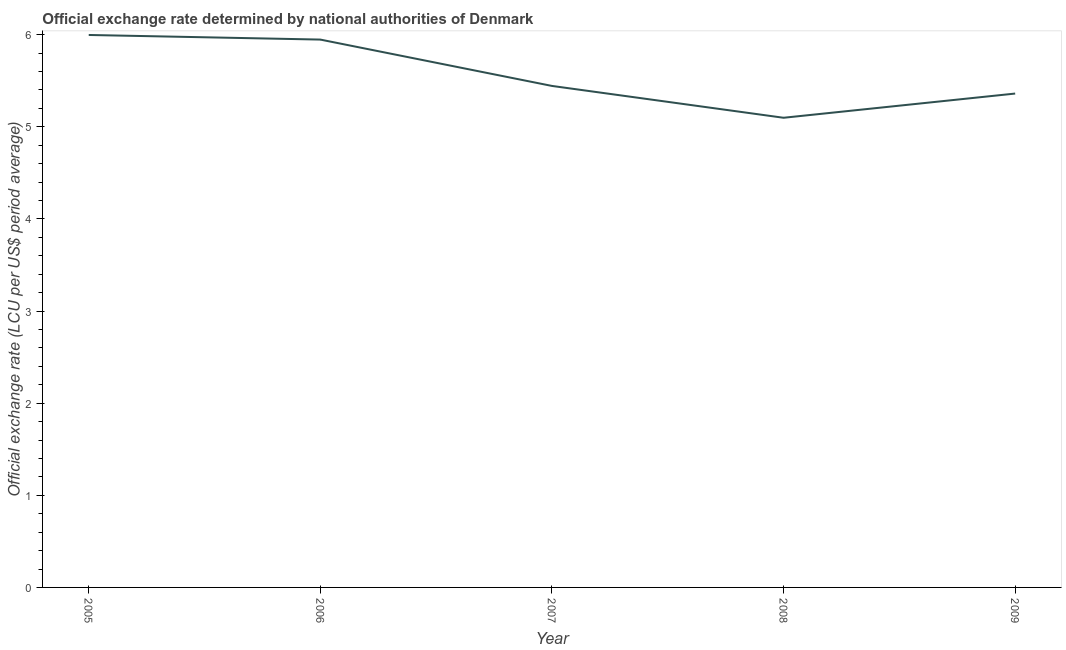What is the official exchange rate in 2009?
Your answer should be very brief. 5.36. Across all years, what is the maximum official exchange rate?
Offer a terse response. 6. Across all years, what is the minimum official exchange rate?
Offer a very short reply. 5.1. What is the sum of the official exchange rate?
Your answer should be compact. 27.85. What is the difference between the official exchange rate in 2006 and 2009?
Give a very brief answer. 0.59. What is the average official exchange rate per year?
Offer a very short reply. 5.57. What is the median official exchange rate?
Your answer should be compact. 5.44. Do a majority of the years between 2005 and 2007 (inclusive) have official exchange rate greater than 2.8 ?
Make the answer very short. Yes. What is the ratio of the official exchange rate in 2006 to that in 2007?
Ensure brevity in your answer.  1.09. Is the difference between the official exchange rate in 2006 and 2009 greater than the difference between any two years?
Offer a very short reply. No. What is the difference between the highest and the second highest official exchange rate?
Offer a very short reply. 0.05. Is the sum of the official exchange rate in 2007 and 2008 greater than the maximum official exchange rate across all years?
Your answer should be very brief. Yes. What is the difference between the highest and the lowest official exchange rate?
Provide a succinct answer. 0.9. Does the official exchange rate monotonically increase over the years?
Make the answer very short. No. How many lines are there?
Ensure brevity in your answer.  1. Are the values on the major ticks of Y-axis written in scientific E-notation?
Your response must be concise. No. Does the graph contain any zero values?
Offer a very short reply. No. Does the graph contain grids?
Provide a succinct answer. No. What is the title of the graph?
Make the answer very short. Official exchange rate determined by national authorities of Denmark. What is the label or title of the X-axis?
Your answer should be compact. Year. What is the label or title of the Y-axis?
Offer a very short reply. Official exchange rate (LCU per US$ period average). What is the Official exchange rate (LCU per US$ period average) in 2005?
Give a very brief answer. 6. What is the Official exchange rate (LCU per US$ period average) of 2006?
Your answer should be very brief. 5.95. What is the Official exchange rate (LCU per US$ period average) of 2007?
Your answer should be very brief. 5.44. What is the Official exchange rate (LCU per US$ period average) of 2008?
Give a very brief answer. 5.1. What is the Official exchange rate (LCU per US$ period average) of 2009?
Provide a succinct answer. 5.36. What is the difference between the Official exchange rate (LCU per US$ period average) in 2005 and 2006?
Give a very brief answer. 0.05. What is the difference between the Official exchange rate (LCU per US$ period average) in 2005 and 2007?
Make the answer very short. 0.55. What is the difference between the Official exchange rate (LCU per US$ period average) in 2005 and 2008?
Give a very brief answer. 0.9. What is the difference between the Official exchange rate (LCU per US$ period average) in 2005 and 2009?
Ensure brevity in your answer.  0.64. What is the difference between the Official exchange rate (LCU per US$ period average) in 2006 and 2007?
Your answer should be compact. 0.5. What is the difference between the Official exchange rate (LCU per US$ period average) in 2006 and 2008?
Your answer should be very brief. 0.85. What is the difference between the Official exchange rate (LCU per US$ period average) in 2006 and 2009?
Provide a short and direct response. 0.59. What is the difference between the Official exchange rate (LCU per US$ period average) in 2007 and 2008?
Your answer should be very brief. 0.35. What is the difference between the Official exchange rate (LCU per US$ period average) in 2007 and 2009?
Ensure brevity in your answer.  0.08. What is the difference between the Official exchange rate (LCU per US$ period average) in 2008 and 2009?
Your response must be concise. -0.26. What is the ratio of the Official exchange rate (LCU per US$ period average) in 2005 to that in 2006?
Make the answer very short. 1.01. What is the ratio of the Official exchange rate (LCU per US$ period average) in 2005 to that in 2007?
Offer a terse response. 1.1. What is the ratio of the Official exchange rate (LCU per US$ period average) in 2005 to that in 2008?
Keep it short and to the point. 1.18. What is the ratio of the Official exchange rate (LCU per US$ period average) in 2005 to that in 2009?
Your response must be concise. 1.12. What is the ratio of the Official exchange rate (LCU per US$ period average) in 2006 to that in 2007?
Your answer should be very brief. 1.09. What is the ratio of the Official exchange rate (LCU per US$ period average) in 2006 to that in 2008?
Keep it short and to the point. 1.17. What is the ratio of the Official exchange rate (LCU per US$ period average) in 2006 to that in 2009?
Keep it short and to the point. 1.11. What is the ratio of the Official exchange rate (LCU per US$ period average) in 2007 to that in 2008?
Your answer should be compact. 1.07. What is the ratio of the Official exchange rate (LCU per US$ period average) in 2008 to that in 2009?
Make the answer very short. 0.95. 